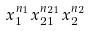Convert formula to latex. <formula><loc_0><loc_0><loc_500><loc_500>x _ { 1 } ^ { n _ { 1 } } x _ { 2 1 } ^ { n _ { 2 1 } } x _ { 2 } ^ { n _ { 2 } }</formula> 